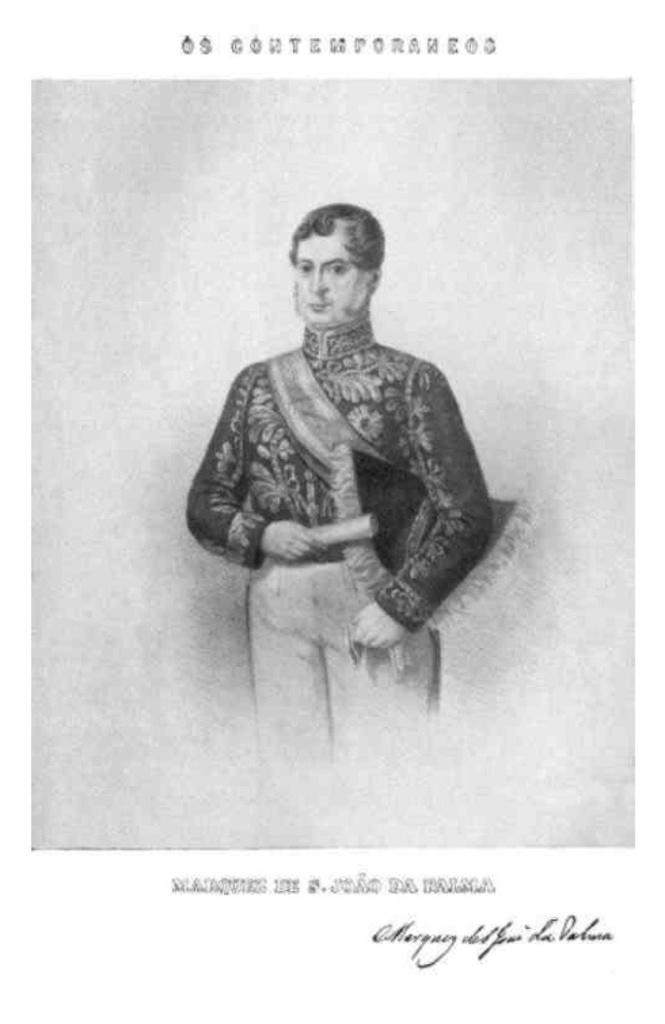What is the main subject of the picture? The main subject of the picture is a sketch of a human. Where can text be found in the picture? Text can be found in the top and bottom of the picture. What type of pot is being used by the nation in the image? There is no pot or nation present in the image; it features a sketch of a human and text. Is the mask being worn by the human in the image? There is no mask present in the image; it only features a sketch of a human and text. 